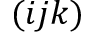<formula> <loc_0><loc_0><loc_500><loc_500>( i j k )</formula> 